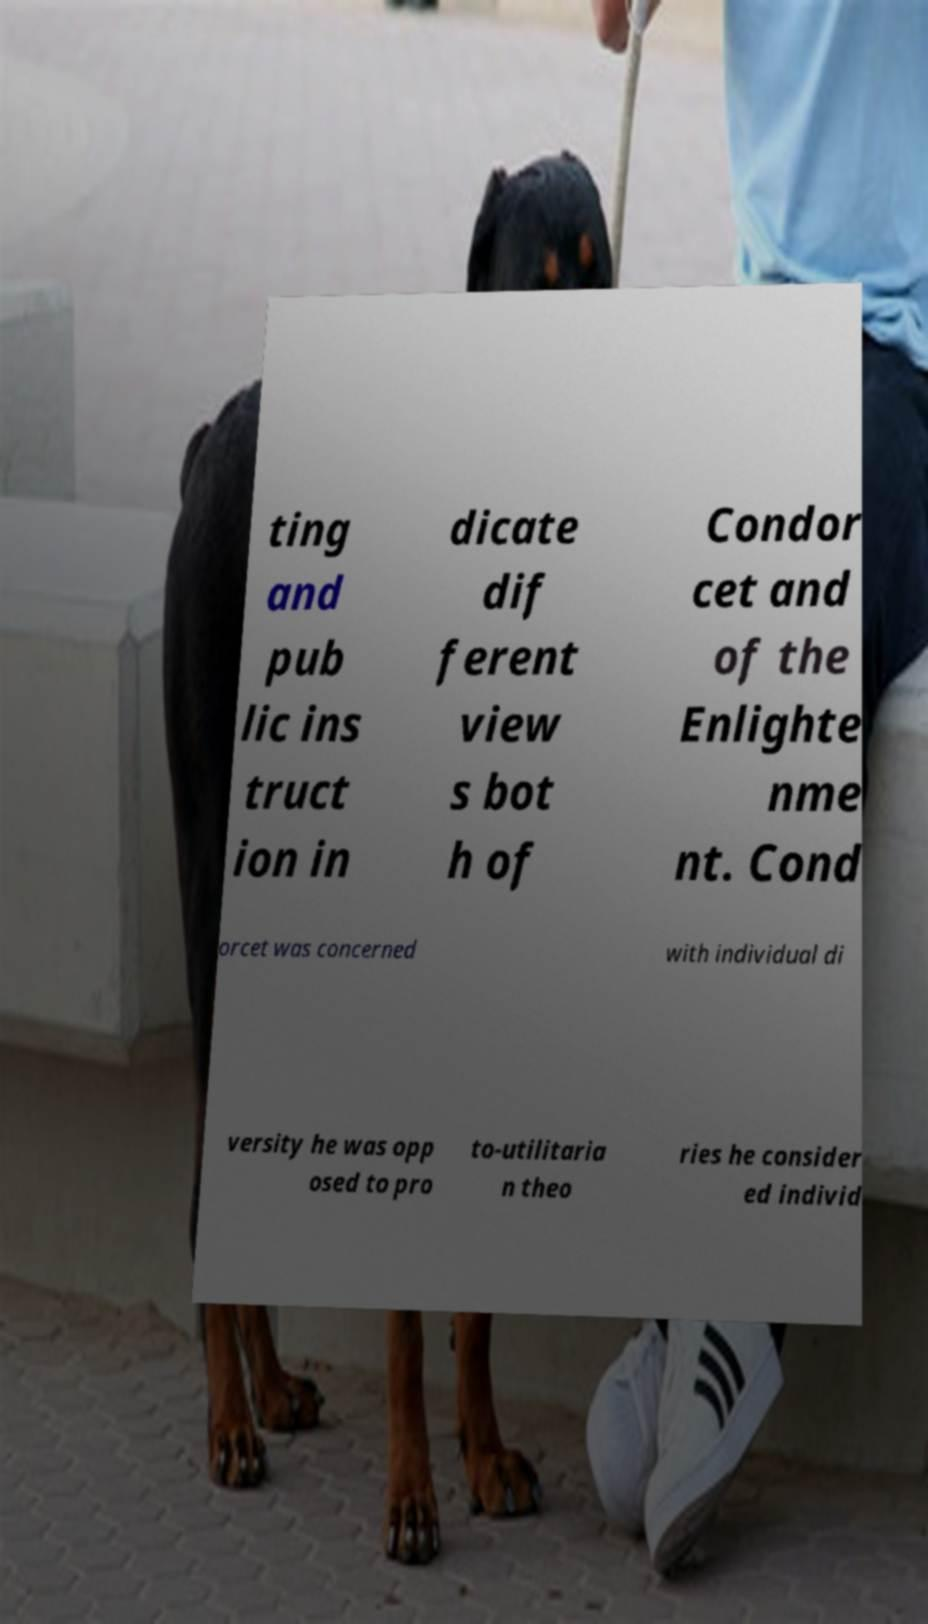Can you accurately transcribe the text from the provided image for me? ting and pub lic ins truct ion in dicate dif ferent view s bot h of Condor cet and of the Enlighte nme nt. Cond orcet was concerned with individual di versity he was opp osed to pro to-utilitaria n theo ries he consider ed individ 